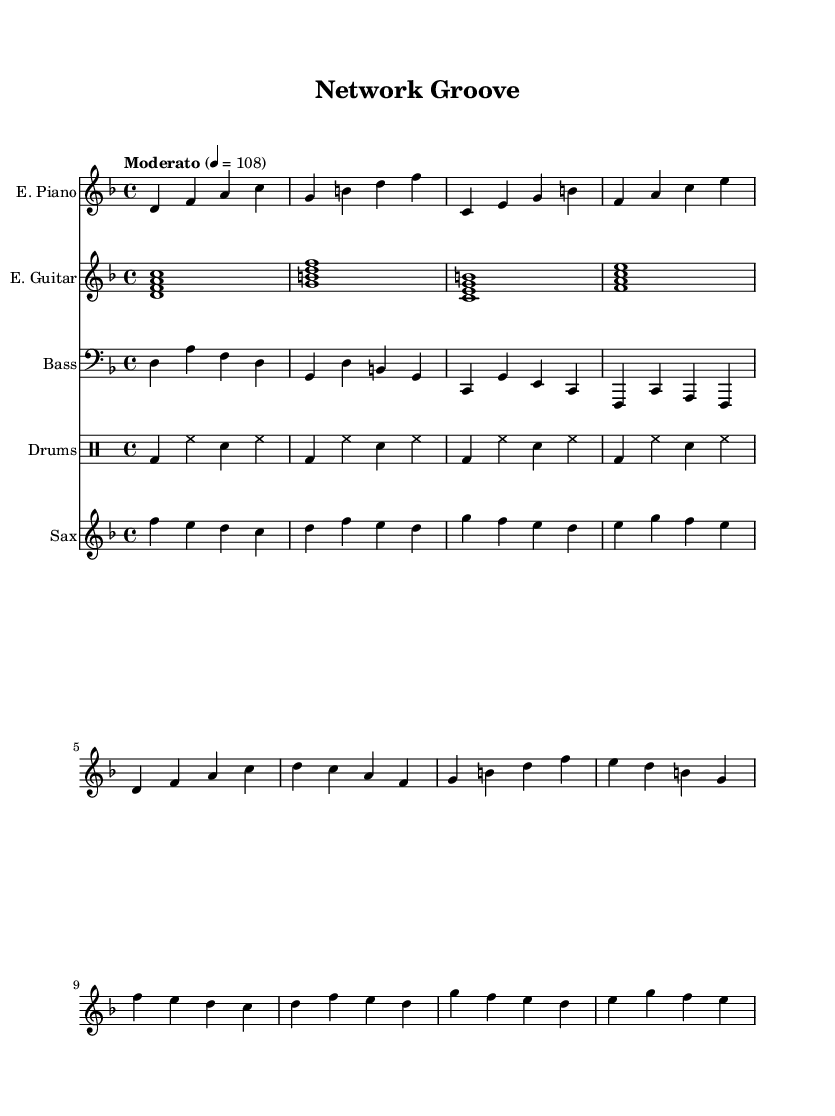What is the key signature of this music? The key signature indicated at the beginning of the piece shows two flats, the notes B flat and E flat, which corresponds to the key of D minor.
Answer: D minor What is the time signature? The time signature is located near the start of the score, showing a 4 atop a 4, which means four beats per measure.
Answer: 4/4 What is the tempo marking? The tempo marking is found in the header section, stating "Moderato" with a metronome marking of 4 = 108, which indicates the speed of the piece.
Answer: Moderato 4 = 108 How many measures are in the electric piano part? By counting the measures written in the electric piano part, we can see there are a total of eight measures in the provided section.
Answer: 8 What is the role of the saxophone in this piece? The saxophone plays a melody that is featured prominently in the chorus section, contributing to the overall texture of the fusion style.
Answer: Melody Which instruments are used in conjunction with the drums? The instruments listed along with the drum staff include electric piano, electric guitar, bass guitar, and saxophone, supporting the overall sound.
Answer: Electric piano, electric guitar, bass guitar, saxophone Identify the primary genre of this piece. The music combines elements of jazz and rock, characterized by improvisation and rhythmic drive, hence it is classified as jazz-rock fusion.
Answer: Jazz-rock fusion 